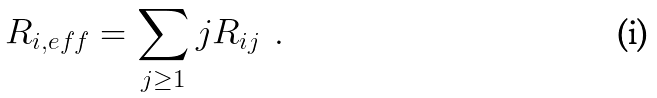Convert formula to latex. <formula><loc_0><loc_0><loc_500><loc_500>R _ { i , e f f } = \sum _ { j \geq 1 } j R _ { i j } \ \ .</formula> 